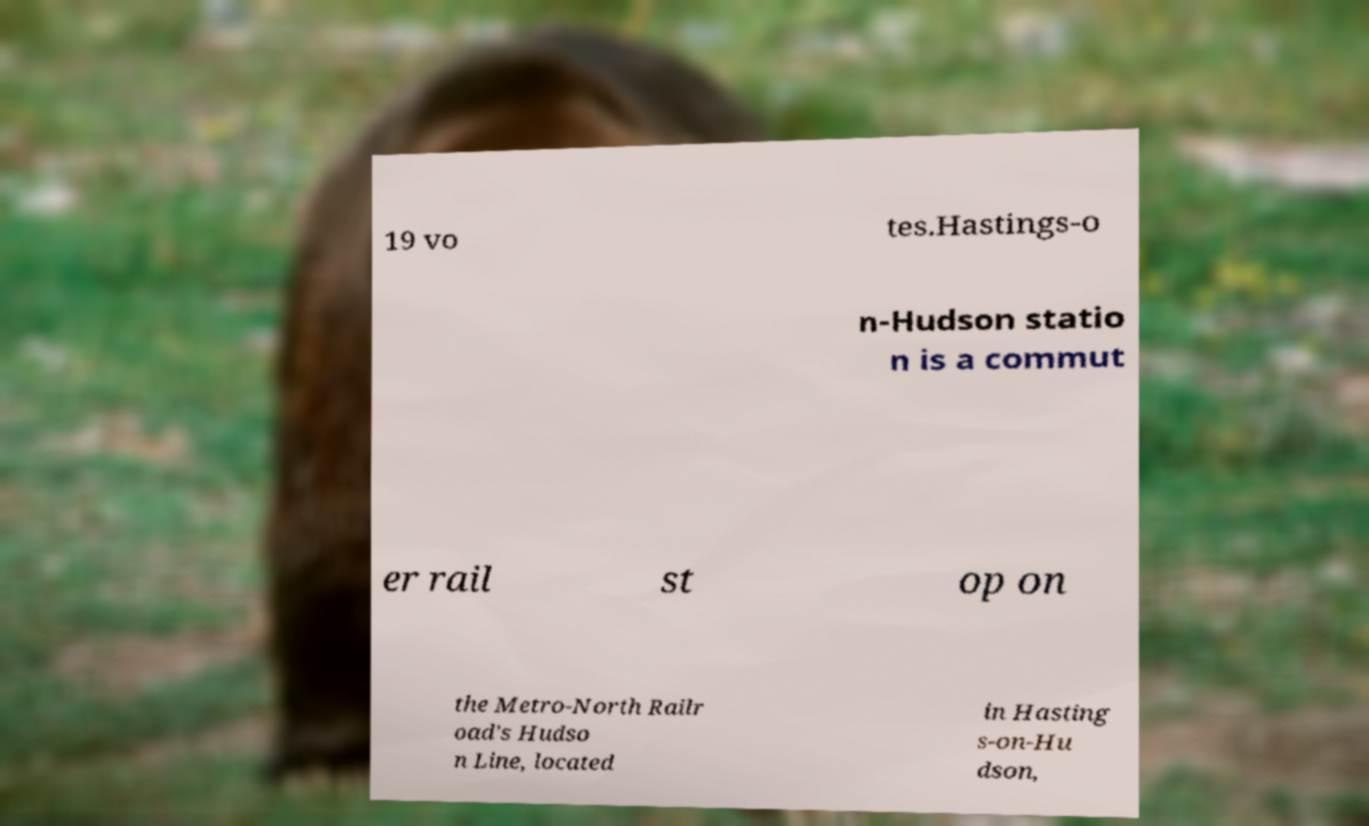Can you accurately transcribe the text from the provided image for me? 19 vo tes.Hastings-o n-Hudson statio n is a commut er rail st op on the Metro-North Railr oad's Hudso n Line, located in Hasting s-on-Hu dson, 